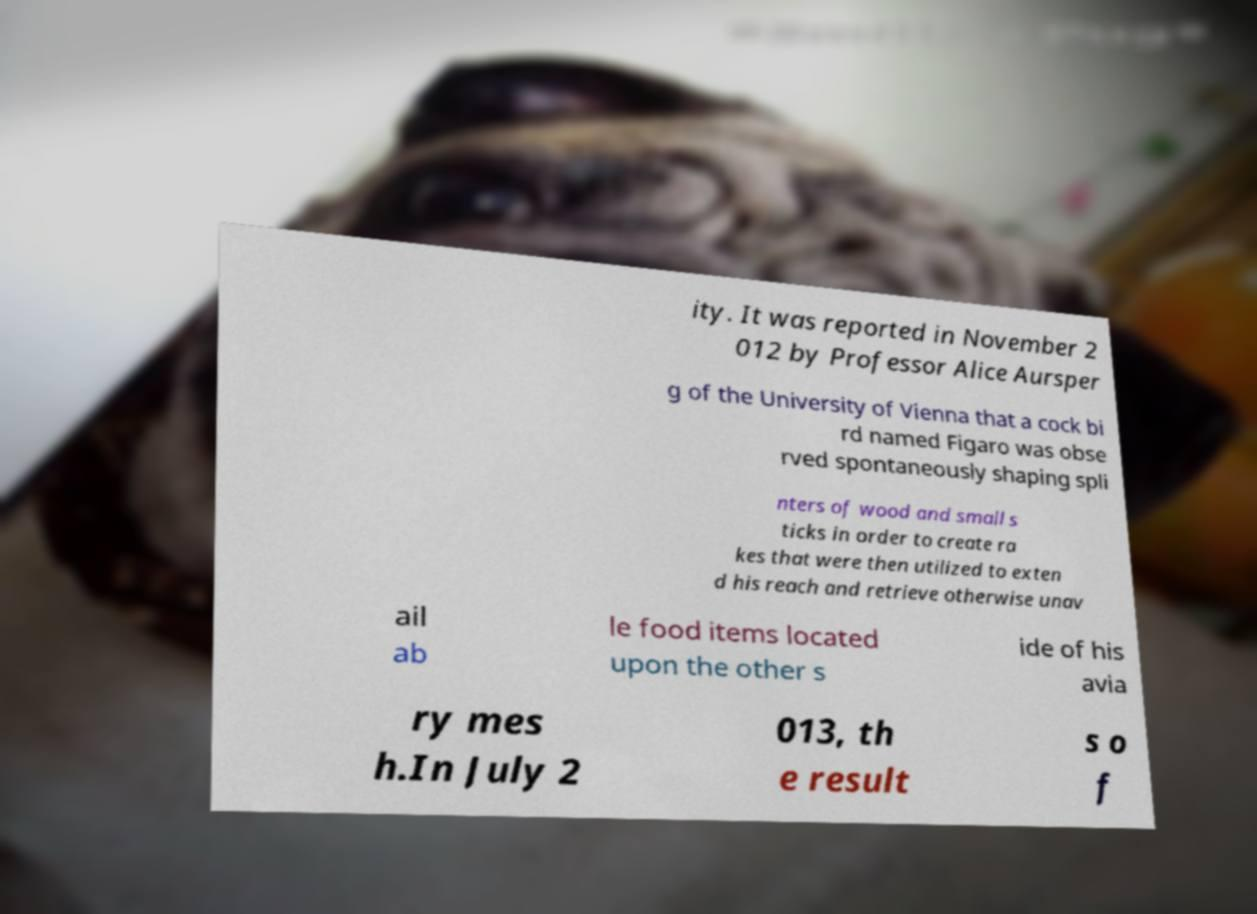Could you assist in decoding the text presented in this image and type it out clearly? ity. It was reported in November 2 012 by Professor Alice Aursper g of the University of Vienna that a cock bi rd named Figaro was obse rved spontaneously shaping spli nters of wood and small s ticks in order to create ra kes that were then utilized to exten d his reach and retrieve otherwise unav ail ab le food items located upon the other s ide of his avia ry mes h.In July 2 013, th e result s o f 